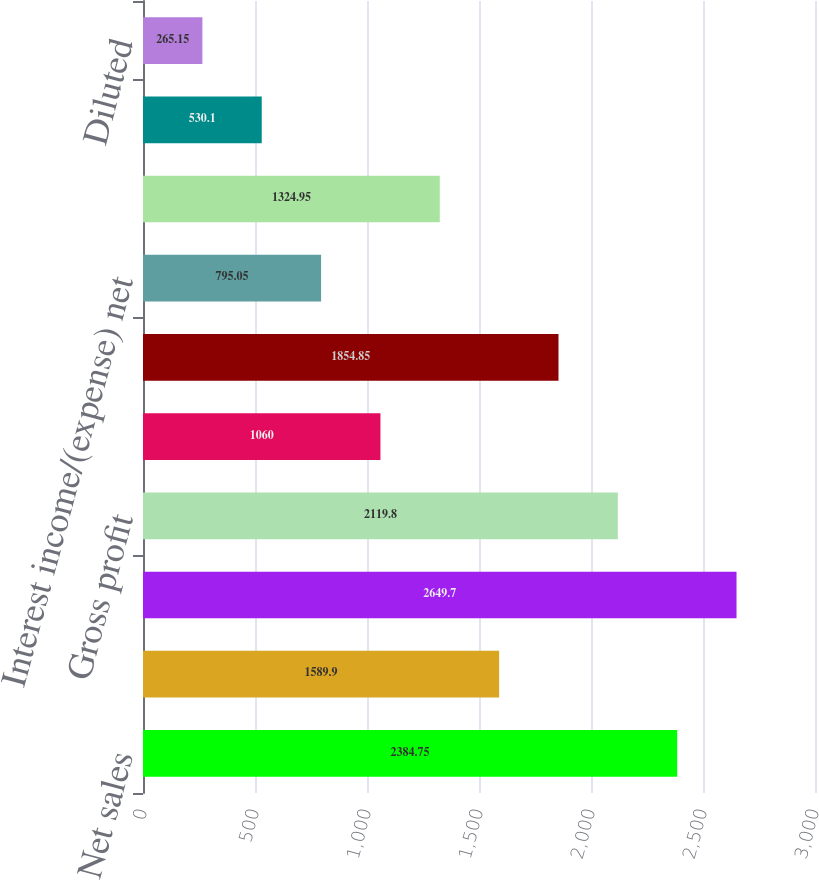Convert chart to OTSL. <chart><loc_0><loc_0><loc_500><loc_500><bar_chart><fcel>Net sales<fcel>Licensing revenues<fcel>Net revenues<fcel>Gross profit<fcel>Depreciation and amortization<fcel>Operating income (c)<fcel>Interest income/(expense) net<fcel>Net income<fcel>Basic<fcel>Diluted<nl><fcel>2384.75<fcel>1589.9<fcel>2649.7<fcel>2119.8<fcel>1060<fcel>1854.85<fcel>795.05<fcel>1324.95<fcel>530.1<fcel>265.15<nl></chart> 